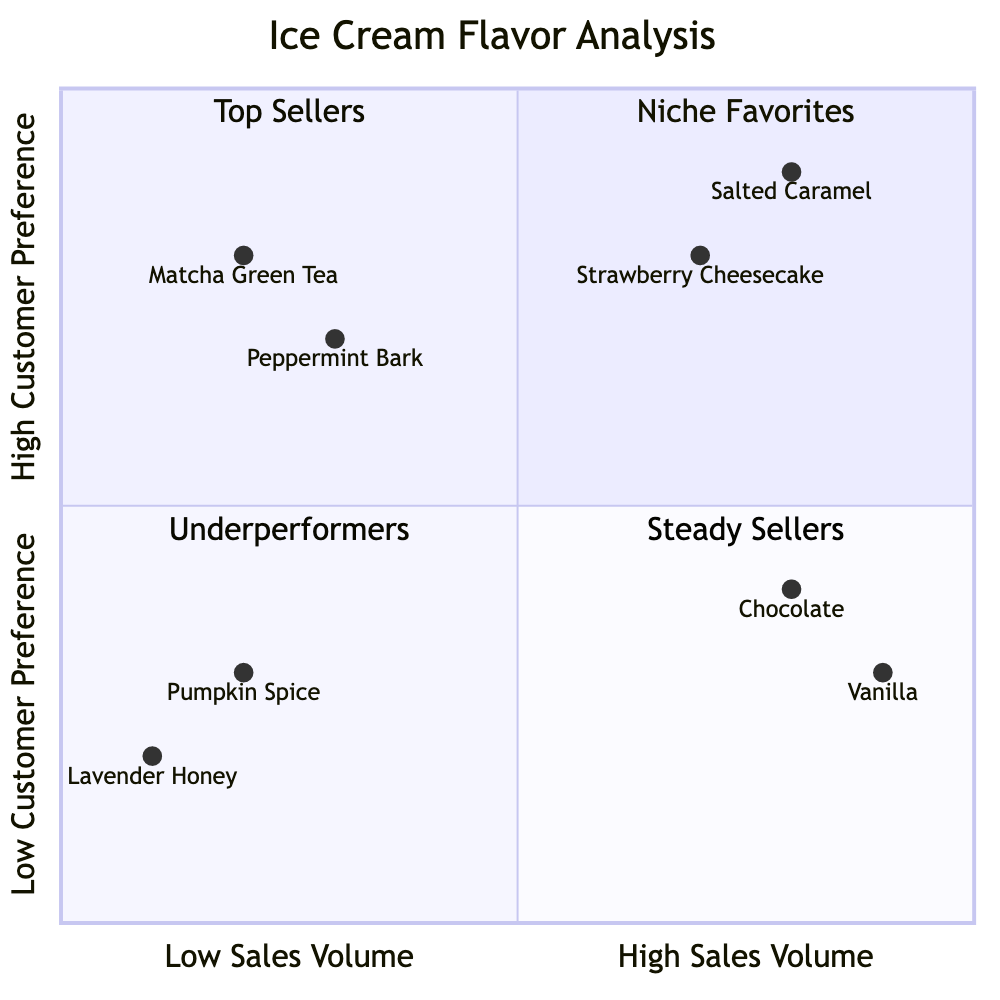What flavors fall under the "Top Sellers" quadrant? The "Top Sellers" quadrant is located in the "High Customer Preference & High Sales Volume" section. The flavors listed in this quadrant are Salted Caramel and Strawberry Cheesecake.
Answer: Salted Caramel, Strawberry Cheesecake Which flavor has the highest customer preference? To determine the flavor with the highest customer preference, we look at the y-axis for the highest value. Salted Caramel at [0.8, 0.9] has the highest preference point, indicating it has the highest customer preference.
Answer: Salted Caramel How many flavors are classified as "Underperformers"? The "Underperformers" quadrant corresponds to "Low Customer Preference & Low Sales Volume." In this quadrant, there are two flavors: Lavender Honey and Pumpkin Spice. Thus, there are two flavors classified here.
Answer: 2 What is the production cost of Chocolate? Chocolate is classified as a "Low Customer Preference & High Sales Volume" flavor, with its production cost mentioned in the data as being "Low." Thus, the production cost of Chocolate is low.
Answer: Low Which flavor has medium production cost in the "Niche Favorites" quadrant? The "Niche Favorites" quadrant includes flavors with high customer preference but low sales volume. In this quadrant, Peppermint Bark has a medium production cost listed.
Answer: Peppermint Bark What seasonality is associated with Matcha Green Tea? Matcha Green Tea is positioned in the "High Customer Preference & Low Sales Volume" quadrant. The data specifies that its seasonality is "Spring." Therefore, the associated seasonality is Spring.
Answer: Spring Which flavor is considered a "Steady Seller"? The "Steady Sellers" quadrant refers to the "Low Customer Preference & High Sales Volume" section. Vanilla and Chocolate are both categorized in this quadrant, indicating they are steady sellers.
Answer: Vanilla, Chocolate Which flavor has the lowest sales volume? To ascertain the flavor with the lowest sales volume, we analyze the chart. The flavors in the "Low Sales Volume" area include Matcha Green Tea, Peppermint Bark, Lavender Honey, and Pumpkin Spice. By comparing their sales volumes, Lavender Honey appears to have the lowest sales volume.
Answer: Lavender Honey How many flavors are categorized as "High Customer Preference"? The "High Customer Preference" quadrant includes flavors from both the "Top Sellers" and "Niche Favorites" sections. Therefore, adding Salted Caramel, Strawberry Cheesecake, Matcha Green Tea, and Peppermint Bark gives a total of four flavors.
Answer: 4 